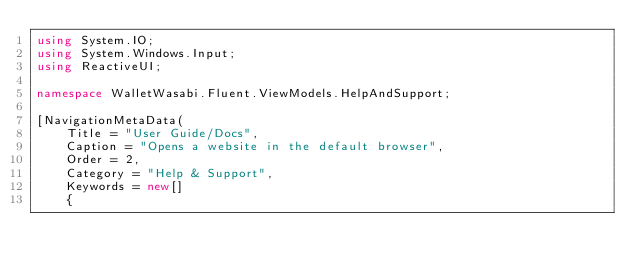<code> <loc_0><loc_0><loc_500><loc_500><_C#_>using System.IO;
using System.Windows.Input;
using ReactiveUI;

namespace WalletWasabi.Fluent.ViewModels.HelpAndSupport;

[NavigationMetaData(
	Title = "User Guide/Docs",
	Caption = "Opens a website in the default browser",
	Order = 2,
	Category = "Help & Support",
	Keywords = new[]
	{</code> 